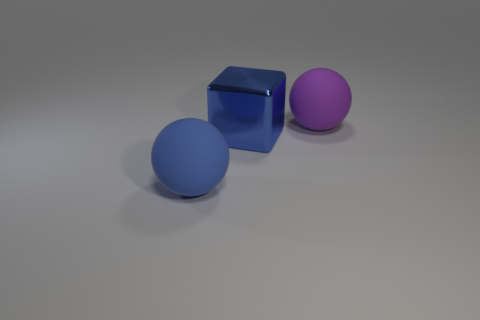There is a rubber thing on the left side of the big matte object behind the sphere in front of the blue metallic object; what shape is it?
Your response must be concise. Sphere. There is a thing that is both behind the blue matte ball and in front of the purple matte sphere; what is its size?
Your response must be concise. Large. How many big cubes are the same color as the metallic thing?
Give a very brief answer. 0. What material is the sphere that is the same color as the large shiny cube?
Provide a succinct answer. Rubber. What material is the big blue cube?
Your answer should be very brief. Metal. Does the sphere left of the big purple rubber sphere have the same material as the large blue cube?
Your answer should be compact. No. There is a rubber thing that is on the left side of the purple sphere; what is its shape?
Provide a short and direct response. Sphere. There is a blue sphere that is the same size as the block; what material is it?
Ensure brevity in your answer.  Rubber. How many objects are either big blue balls in front of the large metallic block or big rubber objects that are right of the large shiny object?
Provide a short and direct response. 2. There is a purple ball that is made of the same material as the large blue sphere; what is its size?
Your response must be concise. Large. 